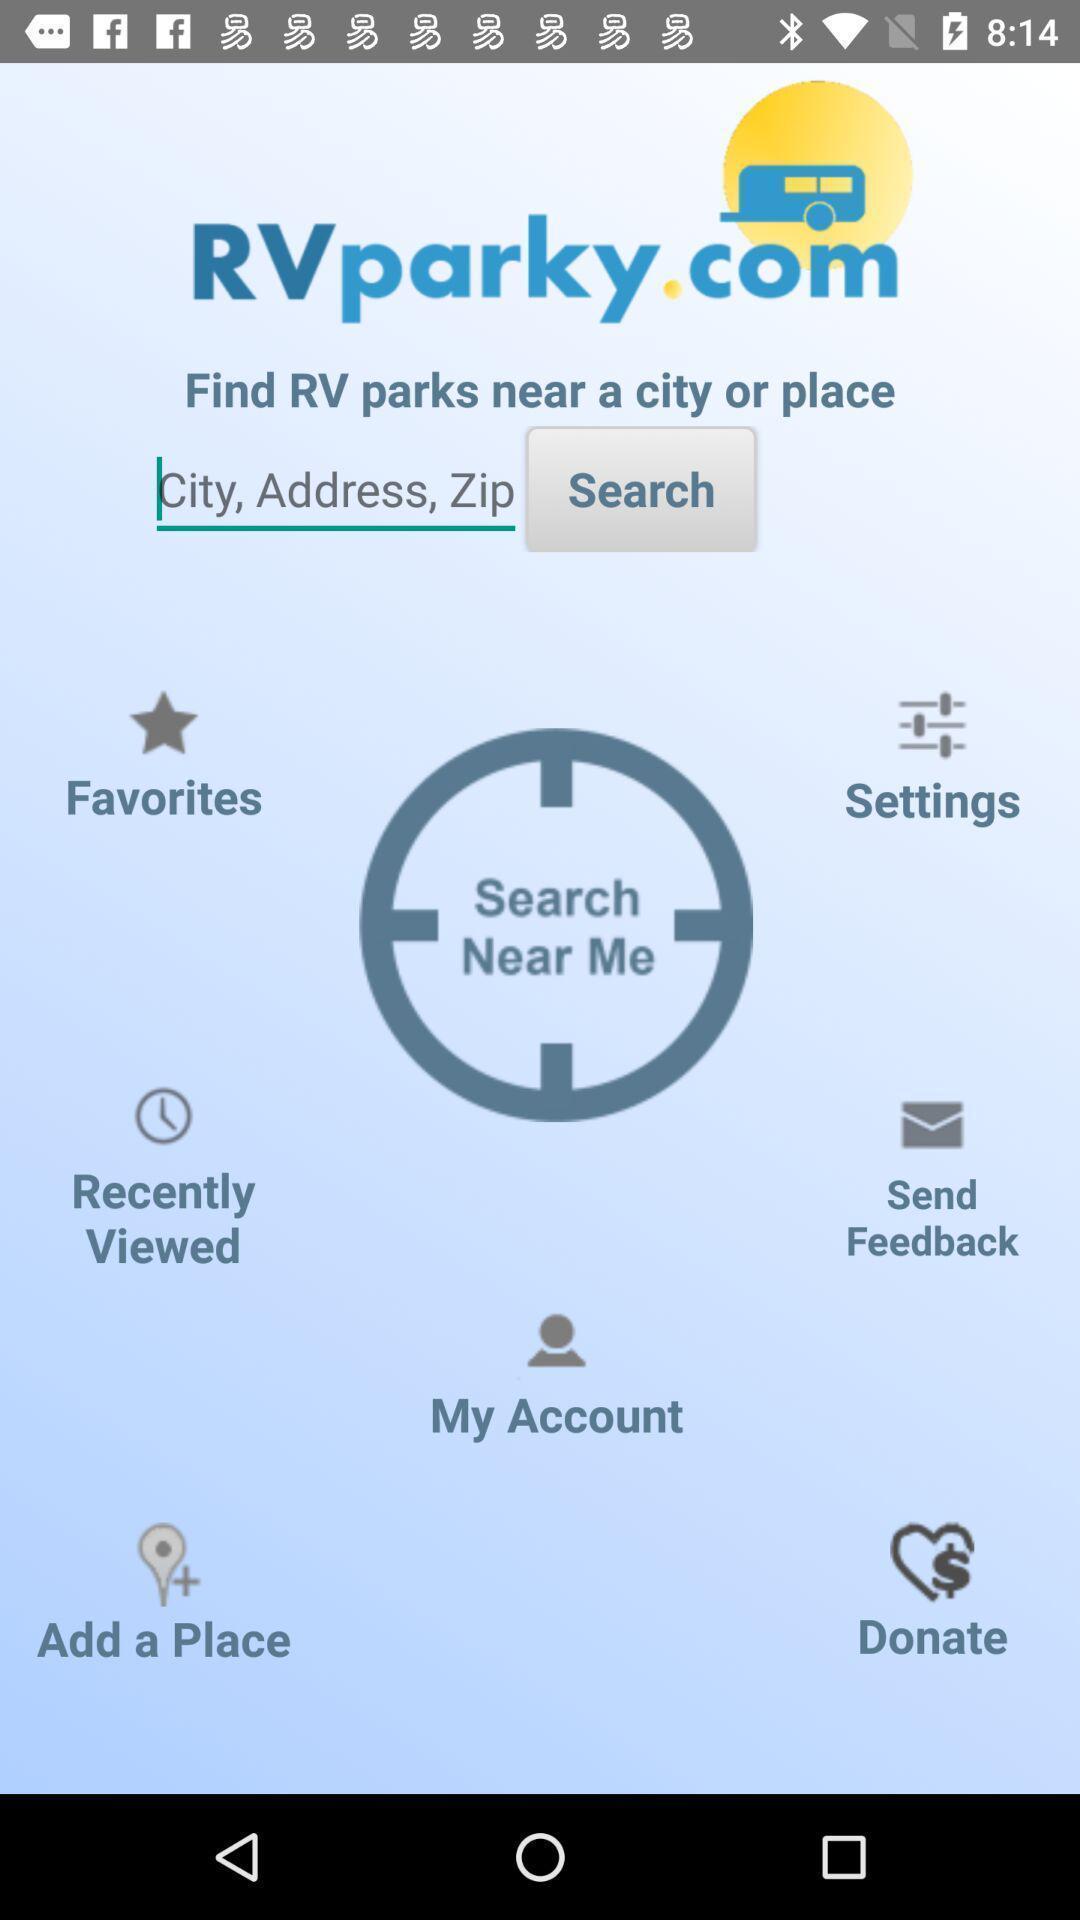Describe this image in words. Screen displaying multiple options in a travelling application. 